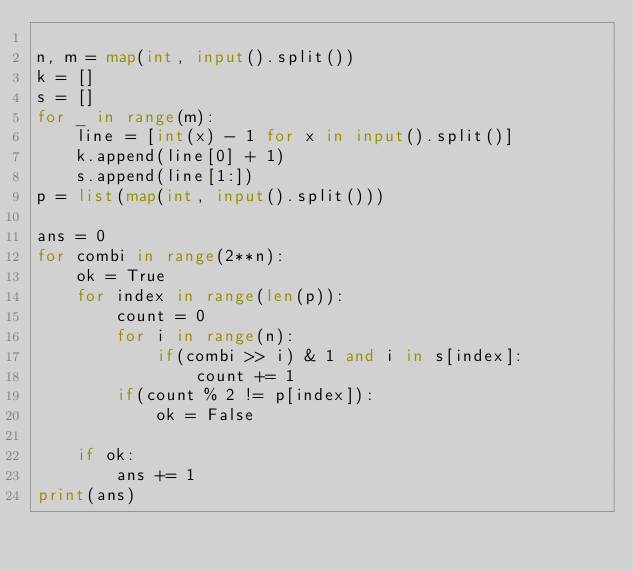<code> <loc_0><loc_0><loc_500><loc_500><_Python_>
n, m = map(int, input().split())
k = []
s = []
for _ in range(m):
    line = [int(x) - 1 for x in input().split()]
    k.append(line[0] + 1)
    s.append(line[1:])
p = list(map(int, input().split()))

ans = 0
for combi in range(2**n):
    ok = True
    for index in range(len(p)):
        count = 0
        for i in range(n):
            if(combi >> i) & 1 and i in s[index]:
                count += 1
        if(count % 2 != p[index]):
            ok = False

    if ok:
        ans += 1
print(ans)</code> 